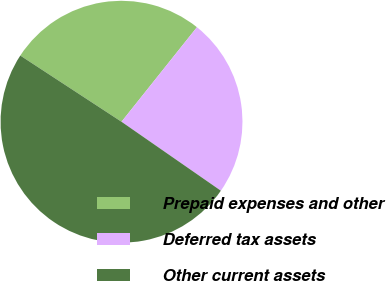Convert chart to OTSL. <chart><loc_0><loc_0><loc_500><loc_500><pie_chart><fcel>Prepaid expenses and other<fcel>Deferred tax assets<fcel>Other current assets<nl><fcel>26.5%<fcel>23.94%<fcel>49.56%<nl></chart> 